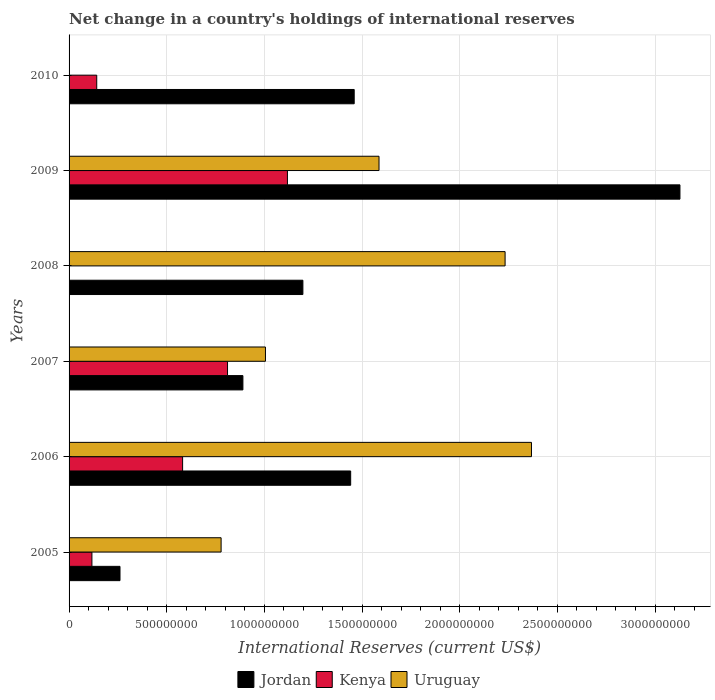Are the number of bars on each tick of the Y-axis equal?
Your response must be concise. No. Across all years, what is the maximum international reserves in Uruguay?
Provide a succinct answer. 2.37e+09. What is the total international reserves in Jordan in the graph?
Your answer should be very brief. 8.38e+09. What is the difference between the international reserves in Jordan in 2005 and that in 2006?
Give a very brief answer. -1.18e+09. What is the difference between the international reserves in Kenya in 2010 and the international reserves in Uruguay in 2009?
Offer a very short reply. -1.45e+09. What is the average international reserves in Kenya per year?
Your response must be concise. 4.62e+08. In the year 2007, what is the difference between the international reserves in Uruguay and international reserves in Jordan?
Offer a very short reply. 1.15e+08. What is the ratio of the international reserves in Kenya in 2009 to that in 2010?
Give a very brief answer. 7.9. Is the international reserves in Jordan in 2009 less than that in 2010?
Provide a short and direct response. No. What is the difference between the highest and the second highest international reserves in Jordan?
Offer a very short reply. 1.67e+09. What is the difference between the highest and the lowest international reserves in Kenya?
Your answer should be very brief. 1.12e+09. Is the sum of the international reserves in Uruguay in 2005 and 2006 greater than the maximum international reserves in Kenya across all years?
Ensure brevity in your answer.  Yes. Is it the case that in every year, the sum of the international reserves in Uruguay and international reserves in Jordan is greater than the international reserves in Kenya?
Ensure brevity in your answer.  Yes. How many years are there in the graph?
Your answer should be compact. 6. Are the values on the major ticks of X-axis written in scientific E-notation?
Offer a very short reply. No. Does the graph contain grids?
Make the answer very short. Yes. Where does the legend appear in the graph?
Your answer should be very brief. Bottom center. How many legend labels are there?
Your answer should be very brief. 3. How are the legend labels stacked?
Your response must be concise. Horizontal. What is the title of the graph?
Your response must be concise. Net change in a country's holdings of international reserves. What is the label or title of the X-axis?
Your response must be concise. International Reserves (current US$). What is the label or title of the Y-axis?
Offer a very short reply. Years. What is the International Reserves (current US$) of Jordan in 2005?
Provide a short and direct response. 2.61e+08. What is the International Reserves (current US$) in Kenya in 2005?
Your answer should be very brief. 1.17e+08. What is the International Reserves (current US$) in Uruguay in 2005?
Offer a very short reply. 7.78e+08. What is the International Reserves (current US$) in Jordan in 2006?
Ensure brevity in your answer.  1.44e+09. What is the International Reserves (current US$) of Kenya in 2006?
Provide a short and direct response. 5.81e+08. What is the International Reserves (current US$) in Uruguay in 2006?
Offer a terse response. 2.37e+09. What is the International Reserves (current US$) of Jordan in 2007?
Your response must be concise. 8.90e+08. What is the International Reserves (current US$) in Kenya in 2007?
Provide a short and direct response. 8.11e+08. What is the International Reserves (current US$) of Uruguay in 2007?
Your answer should be compact. 1.01e+09. What is the International Reserves (current US$) of Jordan in 2008?
Offer a terse response. 1.20e+09. What is the International Reserves (current US$) in Kenya in 2008?
Make the answer very short. 0. What is the International Reserves (current US$) in Uruguay in 2008?
Your response must be concise. 2.23e+09. What is the International Reserves (current US$) in Jordan in 2009?
Keep it short and to the point. 3.13e+09. What is the International Reserves (current US$) in Kenya in 2009?
Provide a short and direct response. 1.12e+09. What is the International Reserves (current US$) of Uruguay in 2009?
Your response must be concise. 1.59e+09. What is the International Reserves (current US$) in Jordan in 2010?
Offer a very short reply. 1.46e+09. What is the International Reserves (current US$) in Kenya in 2010?
Make the answer very short. 1.42e+08. What is the International Reserves (current US$) of Uruguay in 2010?
Provide a short and direct response. 0. Across all years, what is the maximum International Reserves (current US$) in Jordan?
Offer a terse response. 3.13e+09. Across all years, what is the maximum International Reserves (current US$) of Kenya?
Ensure brevity in your answer.  1.12e+09. Across all years, what is the maximum International Reserves (current US$) in Uruguay?
Provide a succinct answer. 2.37e+09. Across all years, what is the minimum International Reserves (current US$) in Jordan?
Provide a short and direct response. 2.61e+08. Across all years, what is the minimum International Reserves (current US$) in Kenya?
Give a very brief answer. 0. Across all years, what is the minimum International Reserves (current US$) of Uruguay?
Provide a short and direct response. 0. What is the total International Reserves (current US$) in Jordan in the graph?
Your answer should be very brief. 8.38e+09. What is the total International Reserves (current US$) of Kenya in the graph?
Offer a terse response. 2.77e+09. What is the total International Reserves (current US$) in Uruguay in the graph?
Your answer should be compact. 7.97e+09. What is the difference between the International Reserves (current US$) in Jordan in 2005 and that in 2006?
Provide a succinct answer. -1.18e+09. What is the difference between the International Reserves (current US$) in Kenya in 2005 and that in 2006?
Provide a short and direct response. -4.64e+08. What is the difference between the International Reserves (current US$) in Uruguay in 2005 and that in 2006?
Provide a succinct answer. -1.59e+09. What is the difference between the International Reserves (current US$) of Jordan in 2005 and that in 2007?
Offer a terse response. -6.29e+08. What is the difference between the International Reserves (current US$) of Kenya in 2005 and that in 2007?
Provide a short and direct response. -6.94e+08. What is the difference between the International Reserves (current US$) of Uruguay in 2005 and that in 2007?
Offer a very short reply. -2.27e+08. What is the difference between the International Reserves (current US$) of Jordan in 2005 and that in 2008?
Your answer should be compact. -9.36e+08. What is the difference between the International Reserves (current US$) of Uruguay in 2005 and that in 2008?
Give a very brief answer. -1.45e+09. What is the difference between the International Reserves (current US$) of Jordan in 2005 and that in 2009?
Keep it short and to the point. -2.87e+09. What is the difference between the International Reserves (current US$) in Kenya in 2005 and that in 2009?
Make the answer very short. -1.00e+09. What is the difference between the International Reserves (current US$) in Uruguay in 2005 and that in 2009?
Give a very brief answer. -8.09e+08. What is the difference between the International Reserves (current US$) in Jordan in 2005 and that in 2010?
Your answer should be very brief. -1.20e+09. What is the difference between the International Reserves (current US$) in Kenya in 2005 and that in 2010?
Your answer should be very brief. -2.46e+07. What is the difference between the International Reserves (current US$) of Jordan in 2006 and that in 2007?
Ensure brevity in your answer.  5.52e+08. What is the difference between the International Reserves (current US$) in Kenya in 2006 and that in 2007?
Make the answer very short. -2.30e+08. What is the difference between the International Reserves (current US$) in Uruguay in 2006 and that in 2007?
Your answer should be very brief. 1.36e+09. What is the difference between the International Reserves (current US$) of Jordan in 2006 and that in 2008?
Ensure brevity in your answer.  2.45e+08. What is the difference between the International Reserves (current US$) of Uruguay in 2006 and that in 2008?
Provide a short and direct response. 1.35e+08. What is the difference between the International Reserves (current US$) in Jordan in 2006 and that in 2009?
Keep it short and to the point. -1.69e+09. What is the difference between the International Reserves (current US$) of Kenya in 2006 and that in 2009?
Ensure brevity in your answer.  -5.37e+08. What is the difference between the International Reserves (current US$) of Uruguay in 2006 and that in 2009?
Your answer should be compact. 7.81e+08. What is the difference between the International Reserves (current US$) in Jordan in 2006 and that in 2010?
Provide a short and direct response. -1.80e+07. What is the difference between the International Reserves (current US$) of Kenya in 2006 and that in 2010?
Make the answer very short. 4.40e+08. What is the difference between the International Reserves (current US$) in Jordan in 2007 and that in 2008?
Make the answer very short. -3.07e+08. What is the difference between the International Reserves (current US$) of Uruguay in 2007 and that in 2008?
Make the answer very short. -1.23e+09. What is the difference between the International Reserves (current US$) of Jordan in 2007 and that in 2009?
Your response must be concise. -2.24e+09. What is the difference between the International Reserves (current US$) in Kenya in 2007 and that in 2009?
Your answer should be compact. -3.07e+08. What is the difference between the International Reserves (current US$) in Uruguay in 2007 and that in 2009?
Your answer should be very brief. -5.81e+08. What is the difference between the International Reserves (current US$) of Jordan in 2007 and that in 2010?
Offer a terse response. -5.70e+08. What is the difference between the International Reserves (current US$) in Kenya in 2007 and that in 2010?
Your answer should be very brief. 6.70e+08. What is the difference between the International Reserves (current US$) in Jordan in 2008 and that in 2009?
Offer a very short reply. -1.93e+09. What is the difference between the International Reserves (current US$) of Uruguay in 2008 and that in 2009?
Ensure brevity in your answer.  6.45e+08. What is the difference between the International Reserves (current US$) of Jordan in 2008 and that in 2010?
Provide a short and direct response. -2.63e+08. What is the difference between the International Reserves (current US$) in Jordan in 2009 and that in 2010?
Your answer should be compact. 1.67e+09. What is the difference between the International Reserves (current US$) of Kenya in 2009 and that in 2010?
Make the answer very short. 9.76e+08. What is the difference between the International Reserves (current US$) of Jordan in 2005 and the International Reserves (current US$) of Kenya in 2006?
Your answer should be compact. -3.21e+08. What is the difference between the International Reserves (current US$) in Jordan in 2005 and the International Reserves (current US$) in Uruguay in 2006?
Your answer should be very brief. -2.11e+09. What is the difference between the International Reserves (current US$) of Kenya in 2005 and the International Reserves (current US$) of Uruguay in 2006?
Your response must be concise. -2.25e+09. What is the difference between the International Reserves (current US$) of Jordan in 2005 and the International Reserves (current US$) of Kenya in 2007?
Give a very brief answer. -5.51e+08. What is the difference between the International Reserves (current US$) of Jordan in 2005 and the International Reserves (current US$) of Uruguay in 2007?
Offer a terse response. -7.45e+08. What is the difference between the International Reserves (current US$) in Kenya in 2005 and the International Reserves (current US$) in Uruguay in 2007?
Your response must be concise. -8.88e+08. What is the difference between the International Reserves (current US$) in Jordan in 2005 and the International Reserves (current US$) in Uruguay in 2008?
Make the answer very short. -1.97e+09. What is the difference between the International Reserves (current US$) in Kenya in 2005 and the International Reserves (current US$) in Uruguay in 2008?
Your answer should be very brief. -2.12e+09. What is the difference between the International Reserves (current US$) in Jordan in 2005 and the International Reserves (current US$) in Kenya in 2009?
Keep it short and to the point. -8.57e+08. What is the difference between the International Reserves (current US$) of Jordan in 2005 and the International Reserves (current US$) of Uruguay in 2009?
Your answer should be very brief. -1.33e+09. What is the difference between the International Reserves (current US$) of Kenya in 2005 and the International Reserves (current US$) of Uruguay in 2009?
Your answer should be very brief. -1.47e+09. What is the difference between the International Reserves (current US$) in Jordan in 2005 and the International Reserves (current US$) in Kenya in 2010?
Keep it short and to the point. 1.19e+08. What is the difference between the International Reserves (current US$) of Jordan in 2006 and the International Reserves (current US$) of Kenya in 2007?
Keep it short and to the point. 6.30e+08. What is the difference between the International Reserves (current US$) of Jordan in 2006 and the International Reserves (current US$) of Uruguay in 2007?
Your answer should be very brief. 4.36e+08. What is the difference between the International Reserves (current US$) of Kenya in 2006 and the International Reserves (current US$) of Uruguay in 2007?
Your answer should be very brief. -4.24e+08. What is the difference between the International Reserves (current US$) of Jordan in 2006 and the International Reserves (current US$) of Uruguay in 2008?
Your answer should be very brief. -7.91e+08. What is the difference between the International Reserves (current US$) of Kenya in 2006 and the International Reserves (current US$) of Uruguay in 2008?
Provide a succinct answer. -1.65e+09. What is the difference between the International Reserves (current US$) of Jordan in 2006 and the International Reserves (current US$) of Kenya in 2009?
Your answer should be compact. 3.24e+08. What is the difference between the International Reserves (current US$) in Jordan in 2006 and the International Reserves (current US$) in Uruguay in 2009?
Provide a short and direct response. -1.45e+08. What is the difference between the International Reserves (current US$) in Kenya in 2006 and the International Reserves (current US$) in Uruguay in 2009?
Offer a very short reply. -1.01e+09. What is the difference between the International Reserves (current US$) in Jordan in 2006 and the International Reserves (current US$) in Kenya in 2010?
Offer a very short reply. 1.30e+09. What is the difference between the International Reserves (current US$) of Jordan in 2007 and the International Reserves (current US$) of Uruguay in 2008?
Offer a very short reply. -1.34e+09. What is the difference between the International Reserves (current US$) of Kenya in 2007 and the International Reserves (current US$) of Uruguay in 2008?
Provide a short and direct response. -1.42e+09. What is the difference between the International Reserves (current US$) of Jordan in 2007 and the International Reserves (current US$) of Kenya in 2009?
Provide a succinct answer. -2.28e+08. What is the difference between the International Reserves (current US$) in Jordan in 2007 and the International Reserves (current US$) in Uruguay in 2009?
Give a very brief answer. -6.97e+08. What is the difference between the International Reserves (current US$) of Kenya in 2007 and the International Reserves (current US$) of Uruguay in 2009?
Provide a succinct answer. -7.76e+08. What is the difference between the International Reserves (current US$) of Jordan in 2007 and the International Reserves (current US$) of Kenya in 2010?
Provide a short and direct response. 7.48e+08. What is the difference between the International Reserves (current US$) of Jordan in 2008 and the International Reserves (current US$) of Kenya in 2009?
Ensure brevity in your answer.  7.91e+07. What is the difference between the International Reserves (current US$) in Jordan in 2008 and the International Reserves (current US$) in Uruguay in 2009?
Make the answer very short. -3.90e+08. What is the difference between the International Reserves (current US$) of Jordan in 2008 and the International Reserves (current US$) of Kenya in 2010?
Provide a succinct answer. 1.06e+09. What is the difference between the International Reserves (current US$) of Jordan in 2009 and the International Reserves (current US$) of Kenya in 2010?
Provide a succinct answer. 2.99e+09. What is the average International Reserves (current US$) of Jordan per year?
Give a very brief answer. 1.40e+09. What is the average International Reserves (current US$) in Kenya per year?
Offer a terse response. 4.62e+08. What is the average International Reserves (current US$) in Uruguay per year?
Provide a succinct answer. 1.33e+09. In the year 2005, what is the difference between the International Reserves (current US$) in Jordan and International Reserves (current US$) in Kenya?
Ensure brevity in your answer.  1.44e+08. In the year 2005, what is the difference between the International Reserves (current US$) of Jordan and International Reserves (current US$) of Uruguay?
Keep it short and to the point. -5.18e+08. In the year 2005, what is the difference between the International Reserves (current US$) of Kenya and International Reserves (current US$) of Uruguay?
Provide a short and direct response. -6.61e+08. In the year 2006, what is the difference between the International Reserves (current US$) in Jordan and International Reserves (current US$) in Kenya?
Provide a short and direct response. 8.60e+08. In the year 2006, what is the difference between the International Reserves (current US$) in Jordan and International Reserves (current US$) in Uruguay?
Provide a short and direct response. -9.26e+08. In the year 2006, what is the difference between the International Reserves (current US$) of Kenya and International Reserves (current US$) of Uruguay?
Give a very brief answer. -1.79e+09. In the year 2007, what is the difference between the International Reserves (current US$) of Jordan and International Reserves (current US$) of Kenya?
Make the answer very short. 7.87e+07. In the year 2007, what is the difference between the International Reserves (current US$) in Jordan and International Reserves (current US$) in Uruguay?
Keep it short and to the point. -1.15e+08. In the year 2007, what is the difference between the International Reserves (current US$) in Kenya and International Reserves (current US$) in Uruguay?
Make the answer very short. -1.94e+08. In the year 2008, what is the difference between the International Reserves (current US$) of Jordan and International Reserves (current US$) of Uruguay?
Your answer should be very brief. -1.04e+09. In the year 2009, what is the difference between the International Reserves (current US$) of Jordan and International Reserves (current US$) of Kenya?
Make the answer very short. 2.01e+09. In the year 2009, what is the difference between the International Reserves (current US$) in Jordan and International Reserves (current US$) in Uruguay?
Provide a succinct answer. 1.54e+09. In the year 2009, what is the difference between the International Reserves (current US$) in Kenya and International Reserves (current US$) in Uruguay?
Make the answer very short. -4.69e+08. In the year 2010, what is the difference between the International Reserves (current US$) of Jordan and International Reserves (current US$) of Kenya?
Give a very brief answer. 1.32e+09. What is the ratio of the International Reserves (current US$) of Jordan in 2005 to that in 2006?
Provide a short and direct response. 0.18. What is the ratio of the International Reserves (current US$) of Kenya in 2005 to that in 2006?
Your answer should be very brief. 0.2. What is the ratio of the International Reserves (current US$) of Uruguay in 2005 to that in 2006?
Keep it short and to the point. 0.33. What is the ratio of the International Reserves (current US$) in Jordan in 2005 to that in 2007?
Provide a succinct answer. 0.29. What is the ratio of the International Reserves (current US$) of Kenya in 2005 to that in 2007?
Keep it short and to the point. 0.14. What is the ratio of the International Reserves (current US$) of Uruguay in 2005 to that in 2007?
Your answer should be compact. 0.77. What is the ratio of the International Reserves (current US$) in Jordan in 2005 to that in 2008?
Provide a short and direct response. 0.22. What is the ratio of the International Reserves (current US$) of Uruguay in 2005 to that in 2008?
Provide a short and direct response. 0.35. What is the ratio of the International Reserves (current US$) of Jordan in 2005 to that in 2009?
Make the answer very short. 0.08. What is the ratio of the International Reserves (current US$) in Kenya in 2005 to that in 2009?
Your answer should be compact. 0.1. What is the ratio of the International Reserves (current US$) of Uruguay in 2005 to that in 2009?
Provide a short and direct response. 0.49. What is the ratio of the International Reserves (current US$) of Jordan in 2005 to that in 2010?
Your answer should be compact. 0.18. What is the ratio of the International Reserves (current US$) of Kenya in 2005 to that in 2010?
Offer a very short reply. 0.83. What is the ratio of the International Reserves (current US$) in Jordan in 2006 to that in 2007?
Your response must be concise. 1.62. What is the ratio of the International Reserves (current US$) of Kenya in 2006 to that in 2007?
Provide a short and direct response. 0.72. What is the ratio of the International Reserves (current US$) in Uruguay in 2006 to that in 2007?
Provide a short and direct response. 2.35. What is the ratio of the International Reserves (current US$) of Jordan in 2006 to that in 2008?
Offer a terse response. 1.2. What is the ratio of the International Reserves (current US$) of Uruguay in 2006 to that in 2008?
Your answer should be very brief. 1.06. What is the ratio of the International Reserves (current US$) of Jordan in 2006 to that in 2009?
Make the answer very short. 0.46. What is the ratio of the International Reserves (current US$) of Kenya in 2006 to that in 2009?
Your response must be concise. 0.52. What is the ratio of the International Reserves (current US$) in Uruguay in 2006 to that in 2009?
Give a very brief answer. 1.49. What is the ratio of the International Reserves (current US$) in Jordan in 2006 to that in 2010?
Keep it short and to the point. 0.99. What is the ratio of the International Reserves (current US$) of Kenya in 2006 to that in 2010?
Offer a very short reply. 4.11. What is the ratio of the International Reserves (current US$) of Jordan in 2007 to that in 2008?
Keep it short and to the point. 0.74. What is the ratio of the International Reserves (current US$) in Uruguay in 2007 to that in 2008?
Your answer should be very brief. 0.45. What is the ratio of the International Reserves (current US$) in Jordan in 2007 to that in 2009?
Make the answer very short. 0.28. What is the ratio of the International Reserves (current US$) in Kenya in 2007 to that in 2009?
Your response must be concise. 0.73. What is the ratio of the International Reserves (current US$) in Uruguay in 2007 to that in 2009?
Provide a short and direct response. 0.63. What is the ratio of the International Reserves (current US$) of Jordan in 2007 to that in 2010?
Offer a terse response. 0.61. What is the ratio of the International Reserves (current US$) of Kenya in 2007 to that in 2010?
Your answer should be very brief. 5.73. What is the ratio of the International Reserves (current US$) of Jordan in 2008 to that in 2009?
Give a very brief answer. 0.38. What is the ratio of the International Reserves (current US$) of Uruguay in 2008 to that in 2009?
Your response must be concise. 1.41. What is the ratio of the International Reserves (current US$) in Jordan in 2008 to that in 2010?
Your answer should be compact. 0.82. What is the ratio of the International Reserves (current US$) of Jordan in 2009 to that in 2010?
Ensure brevity in your answer.  2.14. What is the ratio of the International Reserves (current US$) in Kenya in 2009 to that in 2010?
Your answer should be compact. 7.9. What is the difference between the highest and the second highest International Reserves (current US$) of Jordan?
Provide a succinct answer. 1.67e+09. What is the difference between the highest and the second highest International Reserves (current US$) of Kenya?
Provide a succinct answer. 3.07e+08. What is the difference between the highest and the second highest International Reserves (current US$) of Uruguay?
Offer a very short reply. 1.35e+08. What is the difference between the highest and the lowest International Reserves (current US$) of Jordan?
Ensure brevity in your answer.  2.87e+09. What is the difference between the highest and the lowest International Reserves (current US$) in Kenya?
Give a very brief answer. 1.12e+09. What is the difference between the highest and the lowest International Reserves (current US$) in Uruguay?
Offer a very short reply. 2.37e+09. 